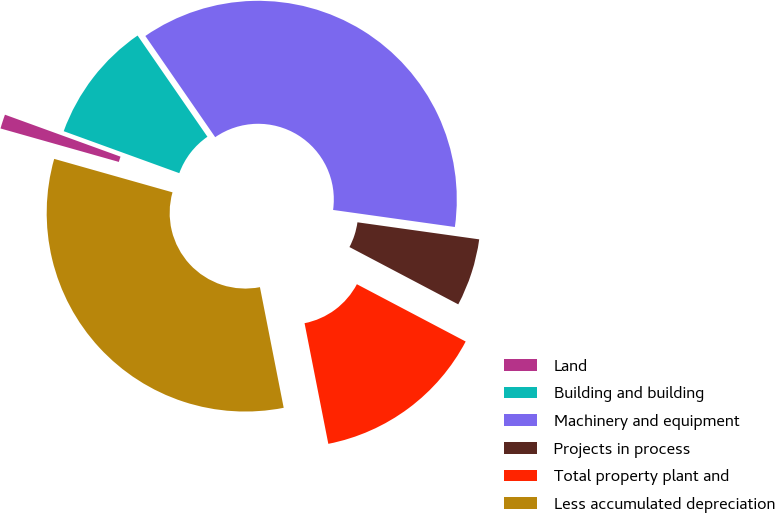Convert chart. <chart><loc_0><loc_0><loc_500><loc_500><pie_chart><fcel>Land<fcel>Building and building<fcel>Machinery and equipment<fcel>Projects in process<fcel>Total property plant and<fcel>Less accumulated depreciation<nl><fcel>1.16%<fcel>9.84%<fcel>36.83%<fcel>5.5%<fcel>14.19%<fcel>32.48%<nl></chart> 